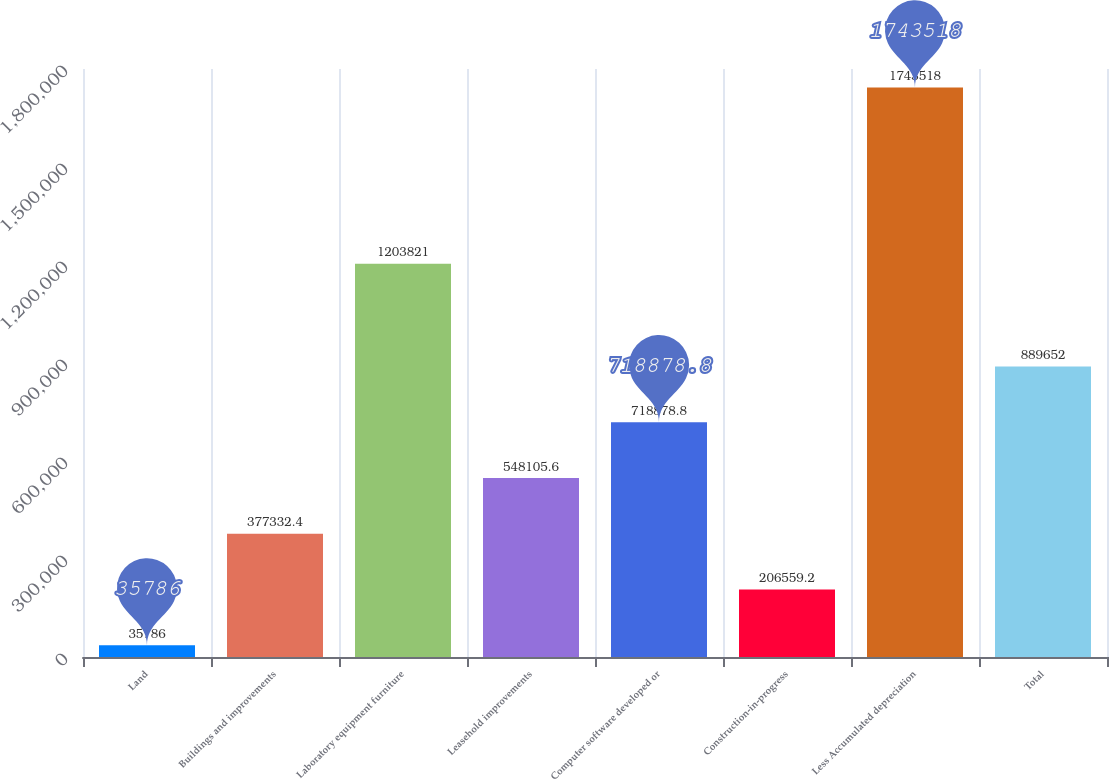<chart> <loc_0><loc_0><loc_500><loc_500><bar_chart><fcel>Land<fcel>Buildings and improvements<fcel>Laboratory equipment furniture<fcel>Leasehold improvements<fcel>Computer software developed or<fcel>Construction-in-progress<fcel>Less Accumulated depreciation<fcel>Total<nl><fcel>35786<fcel>377332<fcel>1.20382e+06<fcel>548106<fcel>718879<fcel>206559<fcel>1.74352e+06<fcel>889652<nl></chart> 